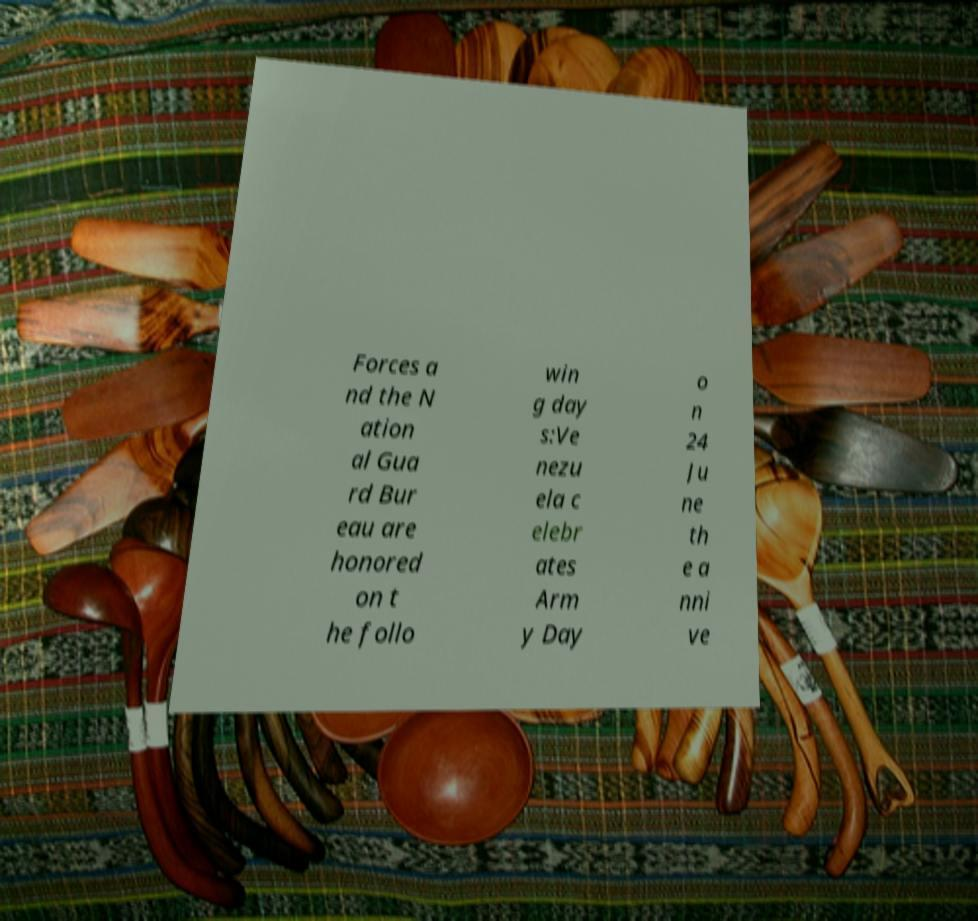I need the written content from this picture converted into text. Can you do that? Forces a nd the N ation al Gua rd Bur eau are honored on t he follo win g day s:Ve nezu ela c elebr ates Arm y Day o n 24 Ju ne th e a nni ve 